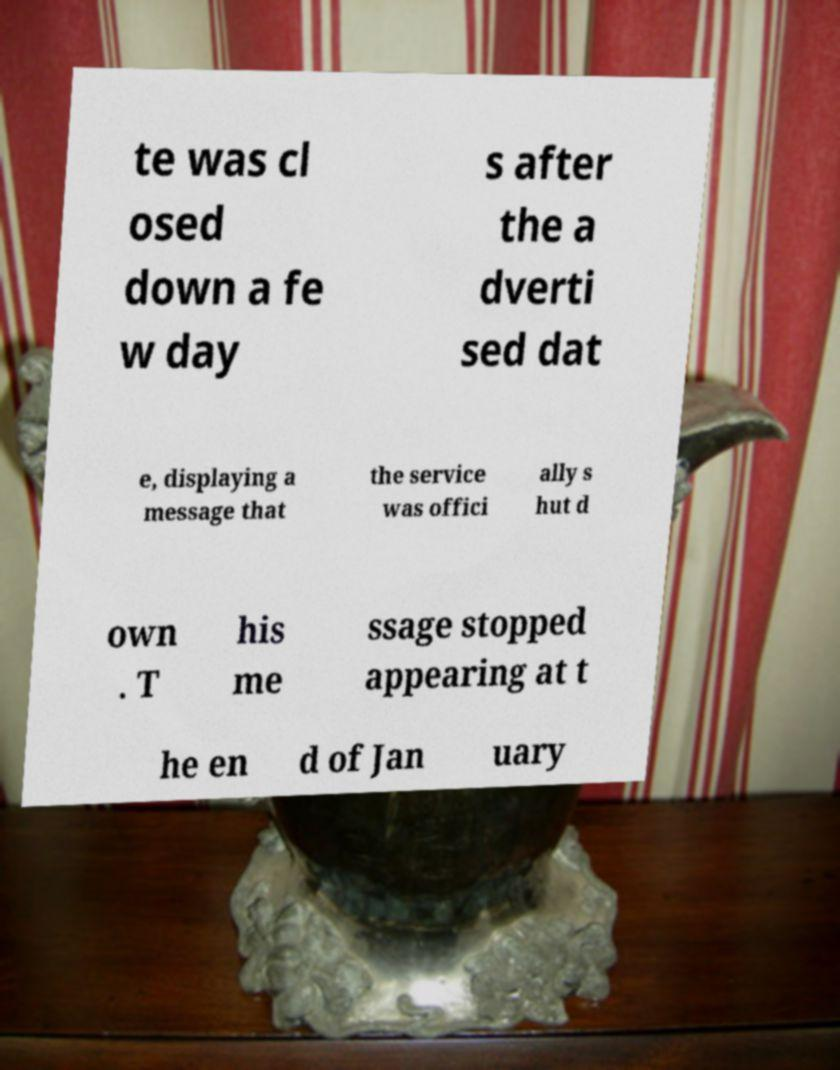Can you read and provide the text displayed in the image?This photo seems to have some interesting text. Can you extract and type it out for me? te was cl osed down a fe w day s after the a dverti sed dat e, displaying a message that the service was offici ally s hut d own . T his me ssage stopped appearing at t he en d of Jan uary 